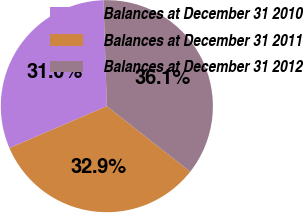Convert chart to OTSL. <chart><loc_0><loc_0><loc_500><loc_500><pie_chart><fcel>Balances at December 31 2010<fcel>Balances at December 31 2011<fcel>Balances at December 31 2012<nl><fcel>30.96%<fcel>32.93%<fcel>36.11%<nl></chart> 